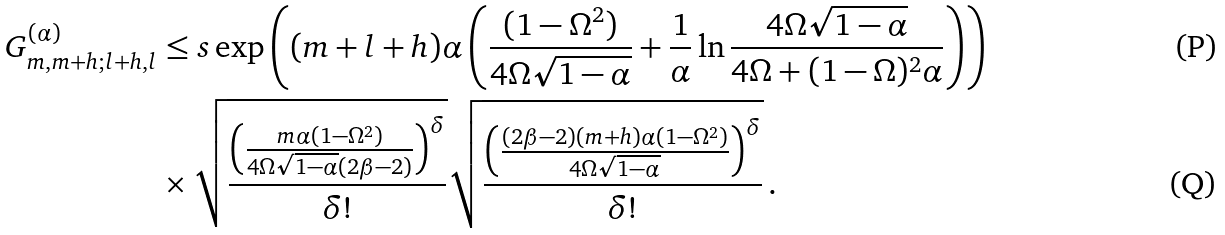<formula> <loc_0><loc_0><loc_500><loc_500>G ^ { ( \alpha ) } _ { m , m + h ; l + h , l } & \leq s \exp \left ( ( m + l + h ) \alpha \left ( \frac { ( 1 - \Omega ^ { 2 } ) } { 4 \Omega \sqrt { 1 - \alpha } } + \frac { 1 } { \alpha } \ln \frac { 4 \Omega \sqrt { 1 - \alpha } } { 4 \Omega + ( 1 - \Omega ) ^ { 2 } \alpha } \right ) \right ) \\ & \times \sqrt { \frac { \left ( \frac { m \alpha ( 1 - \Omega ^ { 2 } ) } { 4 \Omega \sqrt { 1 - \alpha } ( 2 \beta - 2 ) } \right ) ^ { \delta } } { \delta ! } } \sqrt { \frac { \left ( \frac { ( 2 \beta - 2 ) ( m + h ) \alpha ( 1 - \Omega ^ { 2 } ) } { 4 \Omega \sqrt { 1 - \alpha } } \right ) ^ { \delta } } { \delta ! } } \, .</formula> 